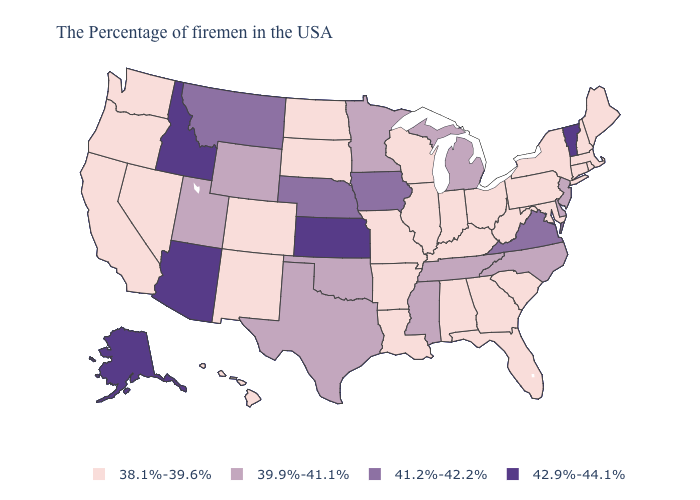Among the states that border Ohio , does Indiana have the highest value?
Write a very short answer. No. Name the states that have a value in the range 38.1%-39.6%?
Short answer required. Maine, Massachusetts, Rhode Island, New Hampshire, Connecticut, New York, Maryland, Pennsylvania, South Carolina, West Virginia, Ohio, Florida, Georgia, Kentucky, Indiana, Alabama, Wisconsin, Illinois, Louisiana, Missouri, Arkansas, South Dakota, North Dakota, Colorado, New Mexico, Nevada, California, Washington, Oregon, Hawaii. Which states hav the highest value in the South?
Give a very brief answer. Virginia. Name the states that have a value in the range 39.9%-41.1%?
Be succinct. New Jersey, Delaware, North Carolina, Michigan, Tennessee, Mississippi, Minnesota, Oklahoma, Texas, Wyoming, Utah. What is the value of Oklahoma?
Quick response, please. 39.9%-41.1%. What is the value of Idaho?
Concise answer only. 42.9%-44.1%. Among the states that border Kansas , does Nebraska have the highest value?
Quick response, please. Yes. Name the states that have a value in the range 39.9%-41.1%?
Answer briefly. New Jersey, Delaware, North Carolina, Michigan, Tennessee, Mississippi, Minnesota, Oklahoma, Texas, Wyoming, Utah. Does Wyoming have a higher value than Nebraska?
Be succinct. No. What is the lowest value in the USA?
Concise answer only. 38.1%-39.6%. What is the highest value in states that border Oregon?
Be succinct. 42.9%-44.1%. What is the value of Mississippi?
Quick response, please. 39.9%-41.1%. Does Missouri have the lowest value in the MidWest?
Write a very short answer. Yes. What is the lowest value in the USA?
Concise answer only. 38.1%-39.6%. Name the states that have a value in the range 38.1%-39.6%?
Be succinct. Maine, Massachusetts, Rhode Island, New Hampshire, Connecticut, New York, Maryland, Pennsylvania, South Carolina, West Virginia, Ohio, Florida, Georgia, Kentucky, Indiana, Alabama, Wisconsin, Illinois, Louisiana, Missouri, Arkansas, South Dakota, North Dakota, Colorado, New Mexico, Nevada, California, Washington, Oregon, Hawaii. 